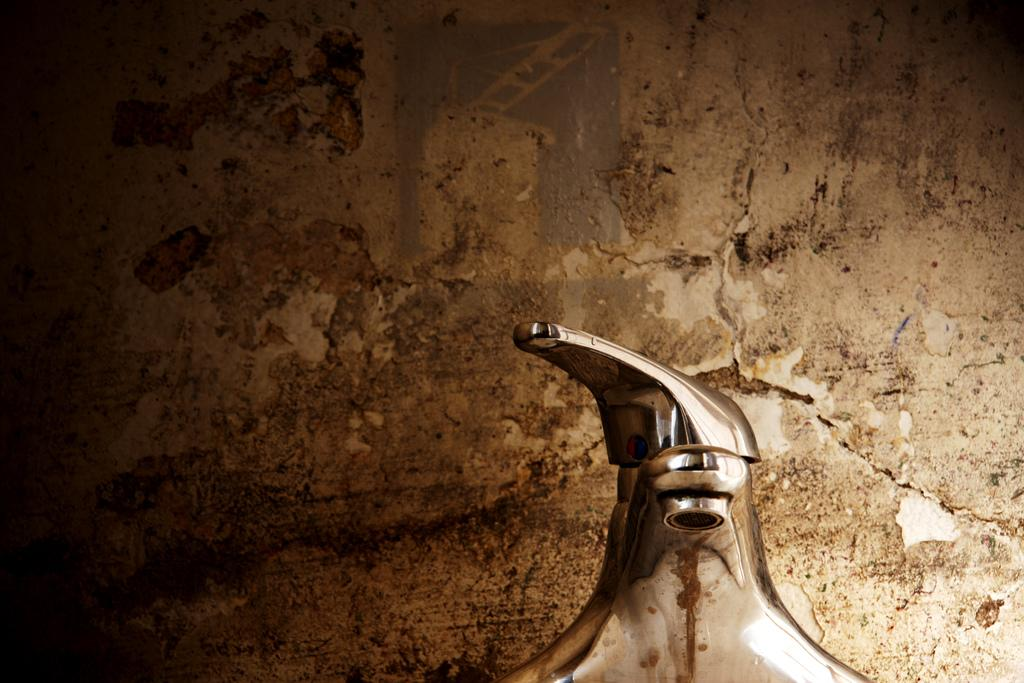What can be seen in the image related to water? There is a water tap in the image. Where is the water tap located in relation to other objects? The water tap is near a wall. How many pears are hanging from the water tap in the image? There are no pears present in the image; it only features a water tap near a wall. 